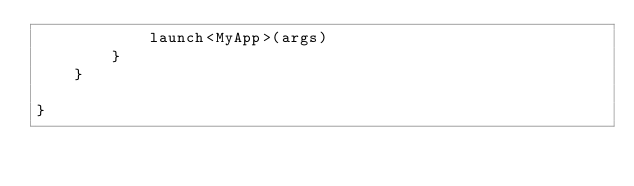<code> <loc_0><loc_0><loc_500><loc_500><_Kotlin_>            launch<MyApp>(args)
        }
    }

}</code> 